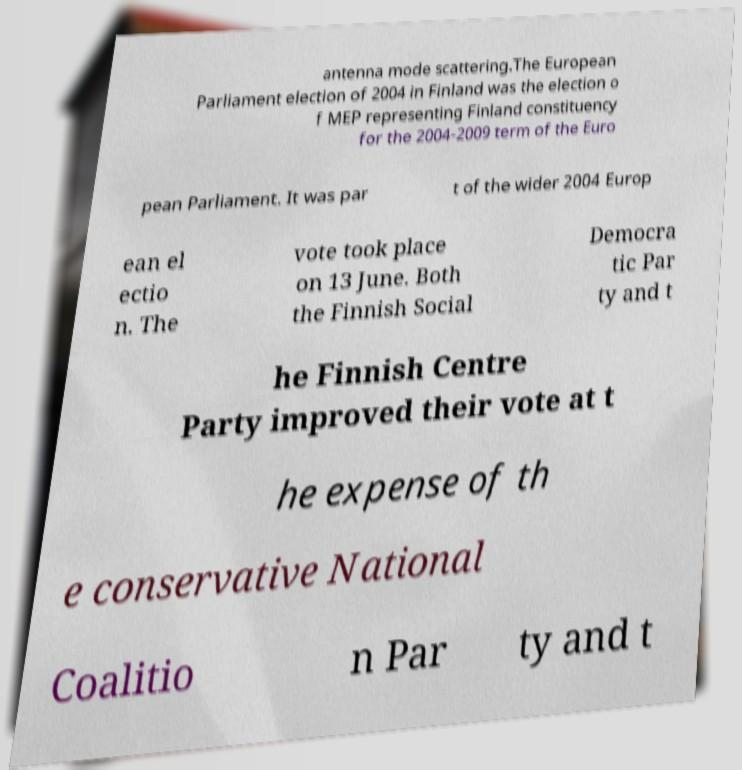Please identify and transcribe the text found in this image. antenna mode scattering.The European Parliament election of 2004 in Finland was the election o f MEP representing Finland constituency for the 2004-2009 term of the Euro pean Parliament. It was par t of the wider 2004 Europ ean el ectio n. The vote took place on 13 June. Both the Finnish Social Democra tic Par ty and t he Finnish Centre Party improved their vote at t he expense of th e conservative National Coalitio n Par ty and t 